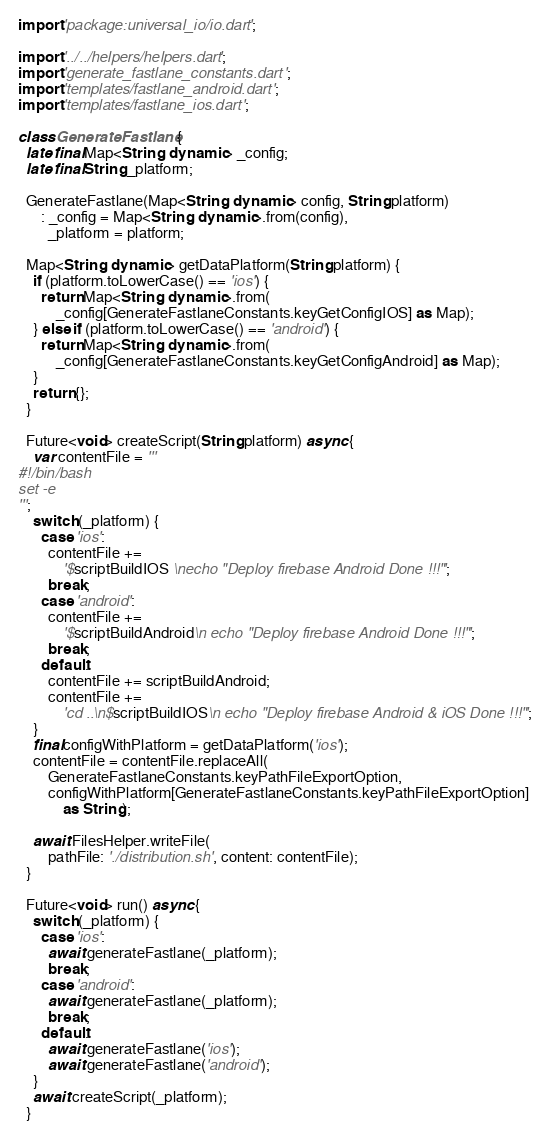Convert code to text. <code><loc_0><loc_0><loc_500><loc_500><_Dart_>import 'package:universal_io/io.dart';

import '../../helpers/helpers.dart';
import 'generate_fastlane_constants.dart';
import 'templates/fastlane_android.dart';
import 'templates/fastlane_ios.dart';

class GenerateFastlane {
  late final Map<String, dynamic> _config;
  late final String _platform;

  GenerateFastlane(Map<String, dynamic> config, String platform)
      : _config = Map<String, dynamic>.from(config),
        _platform = platform;

  Map<String, dynamic> getDataPlatform(String platform) {
    if (platform.toLowerCase() == 'ios') {
      return Map<String, dynamic>.from(
          _config[GenerateFastlaneConstants.keyGetConfigIOS] as Map);
    } else if (platform.toLowerCase() == 'android') {
      return Map<String, dynamic>.from(
          _config[GenerateFastlaneConstants.keyGetConfigAndroid] as Map);
    }
    return {};
  }

  Future<void> createScript(String platform) async {
    var contentFile = '''
#!/bin/bash
set -e
''';
    switch (_platform) {
      case 'ios':
        contentFile +=
            '$scriptBuildIOS \necho "Deploy firebase Android Done !!!"';
        break;
      case 'android':
        contentFile +=
            '$scriptBuildAndroid\n echo "Deploy firebase Android Done !!!"';
        break;
      default:
        contentFile += scriptBuildAndroid;
        contentFile +=
            'cd ..\n$scriptBuildIOS\n echo "Deploy firebase Android & iOS Done !!!"';
    }
    final configWithPlatform = getDataPlatform('ios');
    contentFile = contentFile.replaceAll(
        GenerateFastlaneConstants.keyPathFileExportOption,
        configWithPlatform[GenerateFastlaneConstants.keyPathFileExportOption]
            as String);

    await FilesHelper.writeFile(
        pathFile: './distribution.sh', content: contentFile);
  }

  Future<void> run() async {
    switch (_platform) {
      case 'ios':
        await generateFastlane(_platform);
        break;
      case 'android':
        await generateFastlane(_platform);
        break;
      default:
        await generateFastlane('ios');
        await generateFastlane('android');
    }
    await createScript(_platform);
  }
</code> 